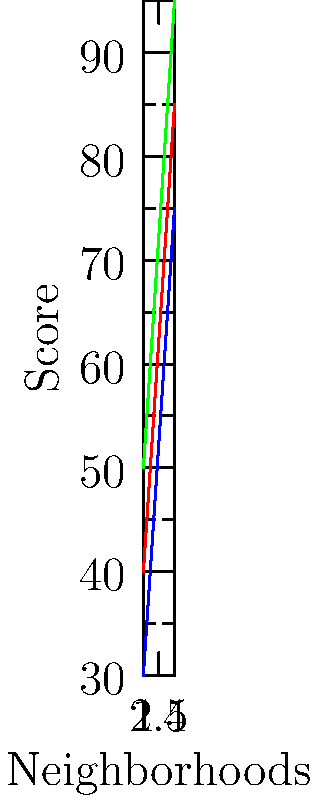Based on the infographic comparing socioeconomic indicators across four neighborhoods, which neighborhood shows the highest overall socioeconomic status, and what pattern can be observed in the relationship between income, education, and health scores? To answer this question, we need to analyze the infographic step-by-step:

1. The graph shows three socioeconomic indicators (income, education, and health) for four different neighborhoods.

2. Let's examine each neighborhood:
   - Neighborhood 1: Lowest scores in all three indicators
   - Neighborhood 2: Second-lowest scores
   - Neighborhood 3: Second-highest scores
   - Neighborhood 4: Highest scores in all three indicators

3. Neighborhood 4 clearly shows the highest overall socioeconomic status, with the highest scores in income, education, and health.

4. Observing the pattern across neighborhoods:
   - As we move from Neighborhood 1 to 4, all three indicators consistently increase.
   - The lines for income, education, and health are roughly parallel, indicating a positive correlation between these factors.
   - Health scores are consistently the highest, followed by education, then income.

5. This pattern suggests that as income increases across neighborhoods, education and health levels also tend to improve, with health showing the most significant improvements.
Answer: Neighborhood 4; positive correlation between income, education, and health, with health scores consistently highest. 